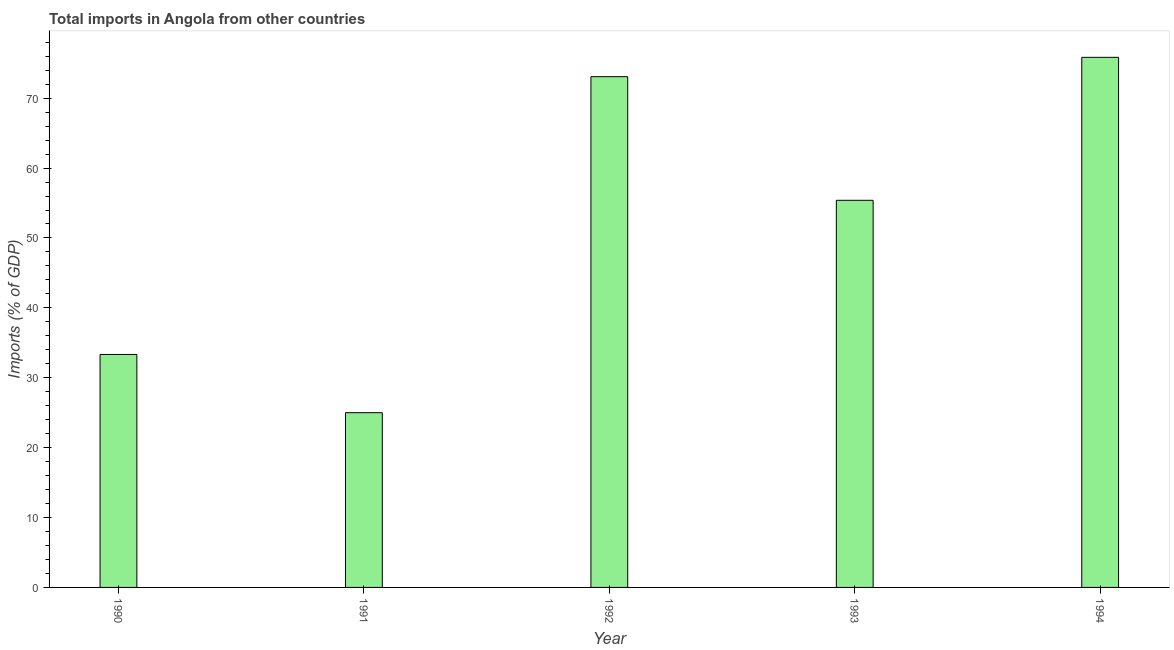What is the title of the graph?
Ensure brevity in your answer.  Total imports in Angola from other countries. What is the label or title of the X-axis?
Make the answer very short. Year. What is the label or title of the Y-axis?
Your answer should be very brief. Imports (% of GDP). What is the total imports in 1992?
Your answer should be very brief. 73.08. Across all years, what is the maximum total imports?
Provide a succinct answer. 75.85. Across all years, what is the minimum total imports?
Your answer should be very brief. 25. In which year was the total imports maximum?
Provide a succinct answer. 1994. In which year was the total imports minimum?
Make the answer very short. 1991. What is the sum of the total imports?
Provide a short and direct response. 262.65. What is the difference between the total imports in 1990 and 1994?
Keep it short and to the point. -42.51. What is the average total imports per year?
Make the answer very short. 52.53. What is the median total imports?
Offer a very short reply. 55.39. In how many years, is the total imports greater than 20 %?
Keep it short and to the point. 5. What is the ratio of the total imports in 1993 to that in 1994?
Offer a very short reply. 0.73. Is the total imports in 1991 less than that in 1994?
Provide a short and direct response. Yes. Is the difference between the total imports in 1990 and 1991 greater than the difference between any two years?
Make the answer very short. No. What is the difference between the highest and the second highest total imports?
Make the answer very short. 2.77. What is the difference between the highest and the lowest total imports?
Your answer should be very brief. 50.85. How many years are there in the graph?
Your answer should be compact. 5. What is the difference between two consecutive major ticks on the Y-axis?
Keep it short and to the point. 10. What is the Imports (% of GDP) of 1990?
Give a very brief answer. 33.33. What is the Imports (% of GDP) in 1991?
Your response must be concise. 25. What is the Imports (% of GDP) in 1992?
Your answer should be very brief. 73.08. What is the Imports (% of GDP) in 1993?
Offer a very short reply. 55.39. What is the Imports (% of GDP) of 1994?
Provide a succinct answer. 75.85. What is the difference between the Imports (% of GDP) in 1990 and 1991?
Provide a succinct answer. 8.33. What is the difference between the Imports (% of GDP) in 1990 and 1992?
Your response must be concise. -39.74. What is the difference between the Imports (% of GDP) in 1990 and 1993?
Your answer should be very brief. -22.06. What is the difference between the Imports (% of GDP) in 1990 and 1994?
Ensure brevity in your answer.  -42.51. What is the difference between the Imports (% of GDP) in 1991 and 1992?
Make the answer very short. -48.08. What is the difference between the Imports (% of GDP) in 1991 and 1993?
Your response must be concise. -30.39. What is the difference between the Imports (% of GDP) in 1991 and 1994?
Make the answer very short. -50.85. What is the difference between the Imports (% of GDP) in 1992 and 1993?
Provide a succinct answer. 17.69. What is the difference between the Imports (% of GDP) in 1992 and 1994?
Ensure brevity in your answer.  -2.77. What is the difference between the Imports (% of GDP) in 1993 and 1994?
Your answer should be very brief. -20.46. What is the ratio of the Imports (% of GDP) in 1990 to that in 1991?
Your response must be concise. 1.33. What is the ratio of the Imports (% of GDP) in 1990 to that in 1992?
Ensure brevity in your answer.  0.46. What is the ratio of the Imports (% of GDP) in 1990 to that in 1993?
Make the answer very short. 0.6. What is the ratio of the Imports (% of GDP) in 1990 to that in 1994?
Keep it short and to the point. 0.44. What is the ratio of the Imports (% of GDP) in 1991 to that in 1992?
Offer a terse response. 0.34. What is the ratio of the Imports (% of GDP) in 1991 to that in 1993?
Keep it short and to the point. 0.45. What is the ratio of the Imports (% of GDP) in 1991 to that in 1994?
Your answer should be very brief. 0.33. What is the ratio of the Imports (% of GDP) in 1992 to that in 1993?
Ensure brevity in your answer.  1.32. What is the ratio of the Imports (% of GDP) in 1992 to that in 1994?
Offer a terse response. 0.96. What is the ratio of the Imports (% of GDP) in 1993 to that in 1994?
Your response must be concise. 0.73. 